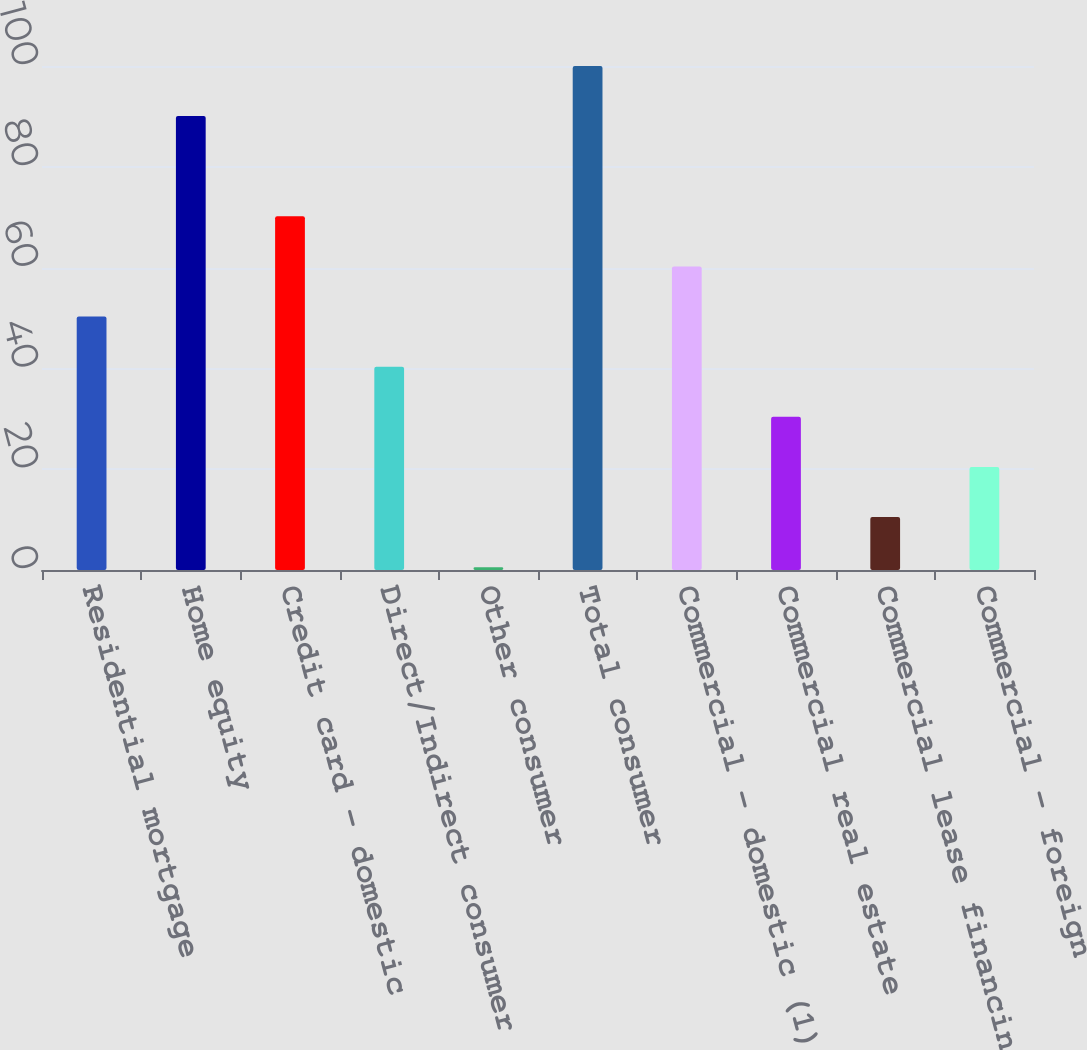Convert chart. <chart><loc_0><loc_0><loc_500><loc_500><bar_chart><fcel>Residential mortgage<fcel>Home equity<fcel>Credit card - domestic<fcel>Direct/Indirect consumer<fcel>Other consumer<fcel>Total consumer<fcel>Commercial - domestic (1)<fcel>Commercial real estate<fcel>Commercial lease financing<fcel>Commercial - foreign<nl><fcel>50.29<fcel>90.06<fcel>70.17<fcel>40.34<fcel>0.55<fcel>100<fcel>60.23<fcel>30.39<fcel>10.5<fcel>20.45<nl></chart> 